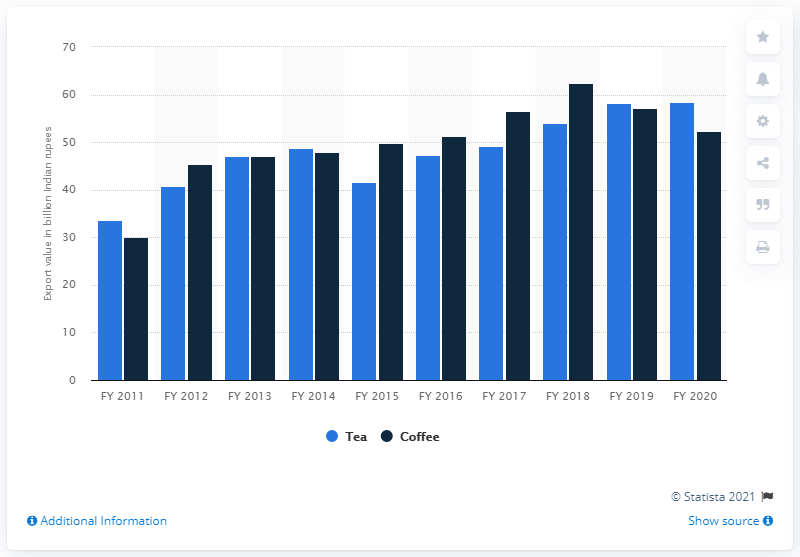Point out several critical features in this image. In the fiscal year 2020, the value of coffee exported from India was 52.37 million. The export value of Indian tea in fiscal year 2020 was 58.51. 